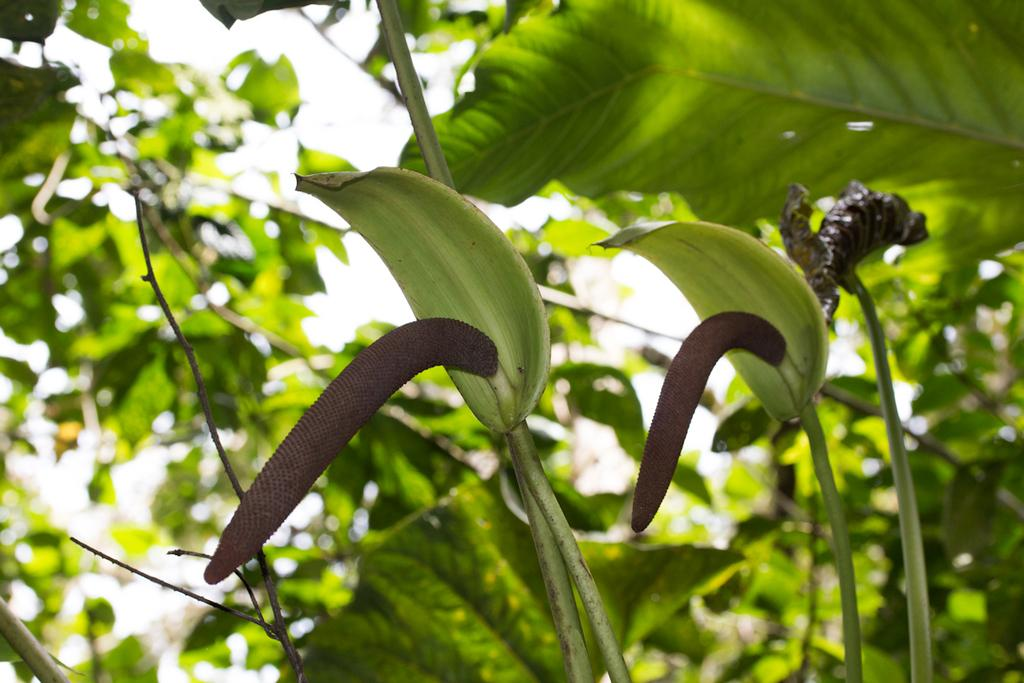What type of living organisms can be seen in the image? Plants can be seen in the image. What is visible at the top of the image? The sky is visible at the top of the image. Can you describe the plants in the foreground of the image? The plants in the foreground might have flowers on them. How many mice are hiding in the plants in the image? There are no mice present in the image; it only features plants and possibly flowers. Can you describe the butter on the plants in the image? There is no butter present on the plants in the image; it only features plants and possibly flowers. 